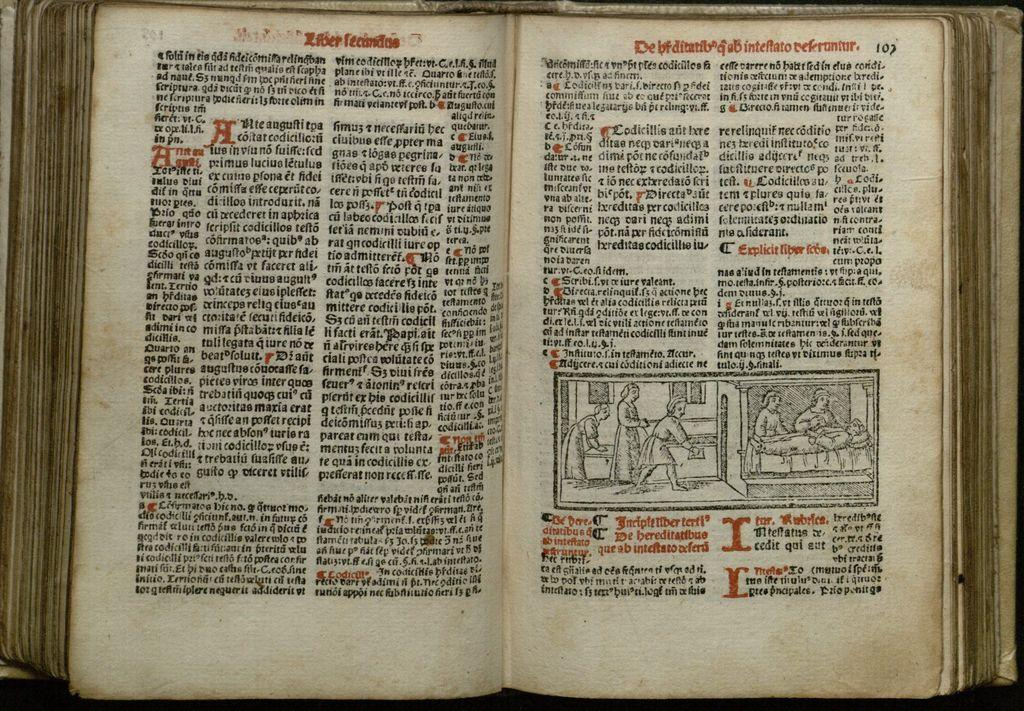<image>
Write a terse but informative summary of the picture. An open book on a table that is on page 107 